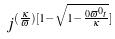Convert formula to latex. <formula><loc_0><loc_0><loc_500><loc_500>j ^ { ( \frac { \kappa } { \varpi } ) [ 1 - \sqrt { 1 - \frac { 0 \varpi ^ { 0 } t } { \kappa } } ] }</formula> 